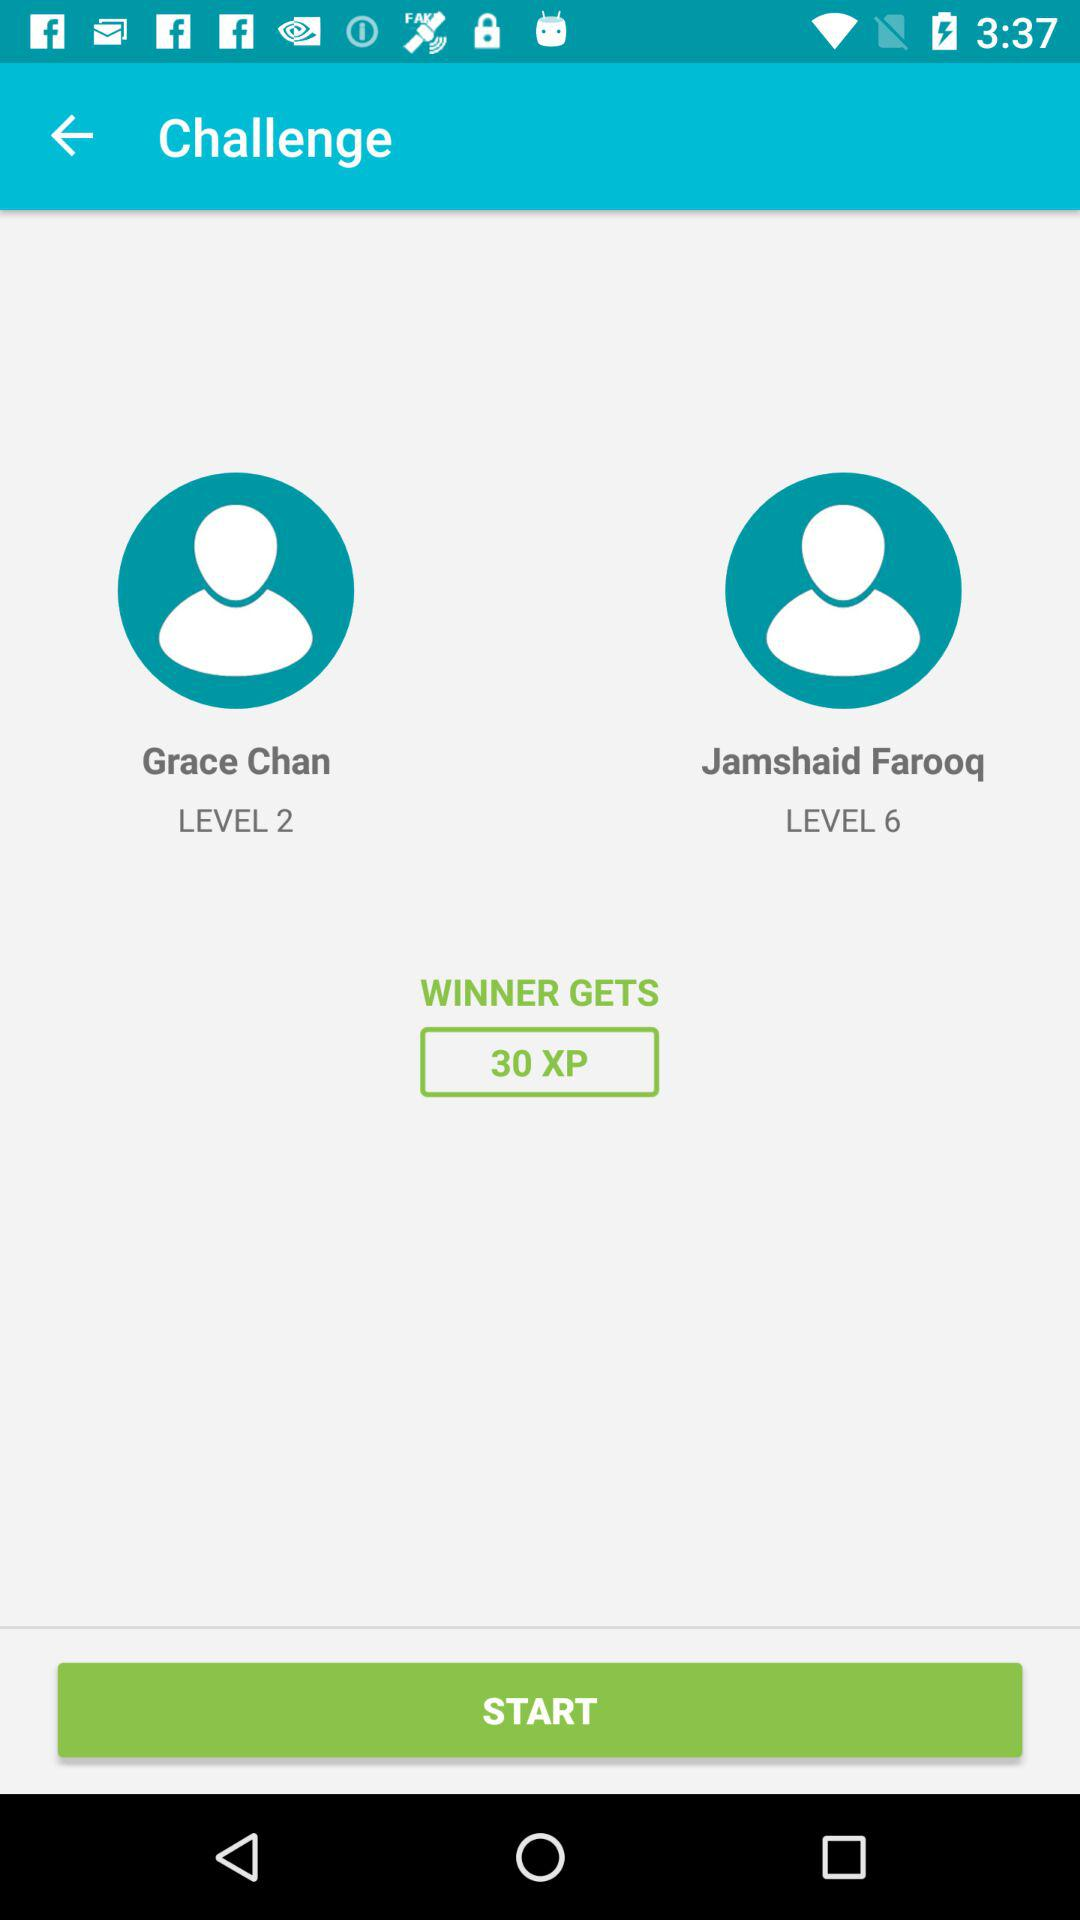How many winning points are there? There are 30 XP winning points. 